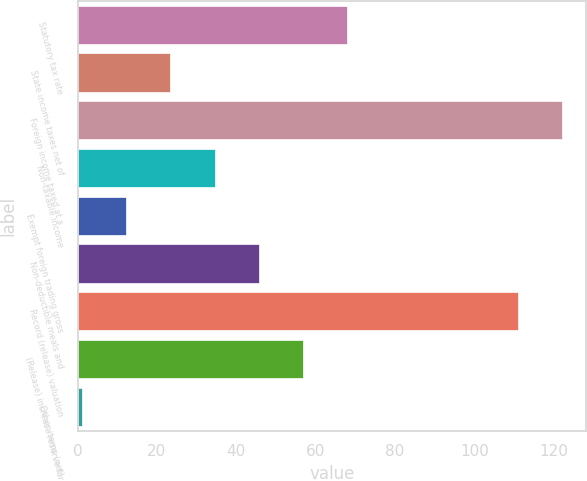<chart> <loc_0><loc_0><loc_500><loc_500><bar_chart><fcel>Statutory tax rate<fcel>State income taxes net of<fcel>Foreign income taxed at a<fcel>Non-taxable income<fcel>Exempt foreign trading gross<fcel>Non-deductible meals and<fcel>Record (release) valuation<fcel>(Release) increase reserve for<fcel>Other items (net)<nl><fcel>67.8<fcel>23.4<fcel>122.1<fcel>34.5<fcel>12.3<fcel>45.6<fcel>111<fcel>56.7<fcel>1.2<nl></chart> 